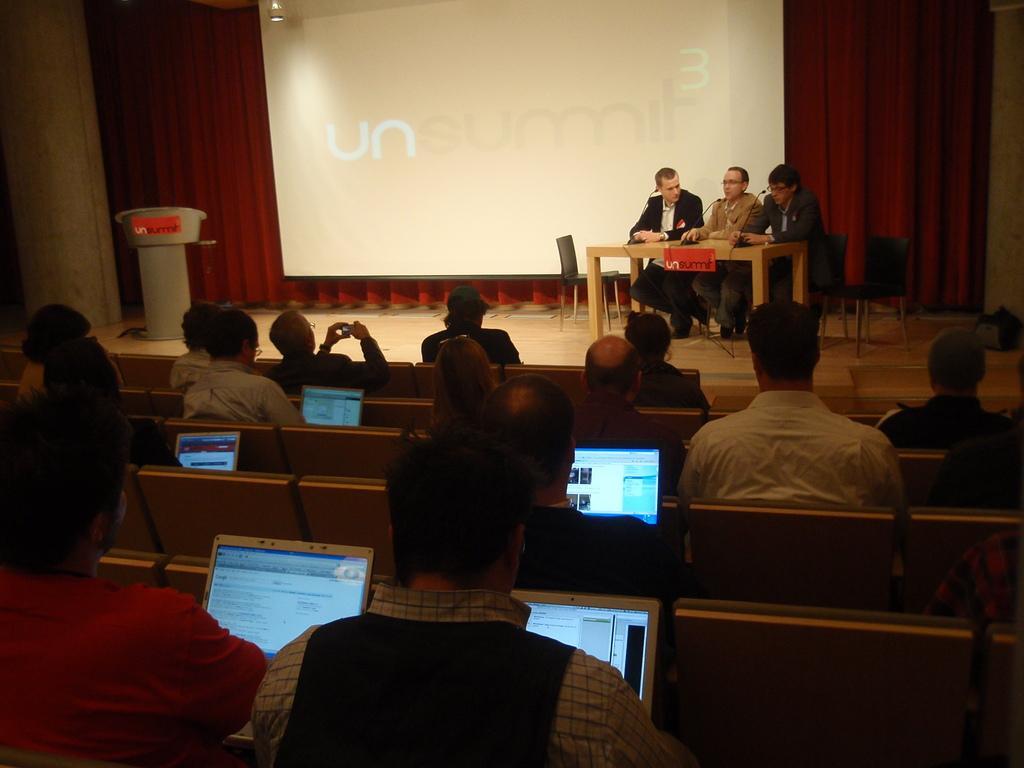In one or two sentences, can you explain what this image depicts? In this picture we can see some people sitting, some of them are looking at laptops, in the background there are three persons sitting on chairs in front of a table, we can see a projector screen and curtain here, on the left side there is a podium, we can see microphones here. 